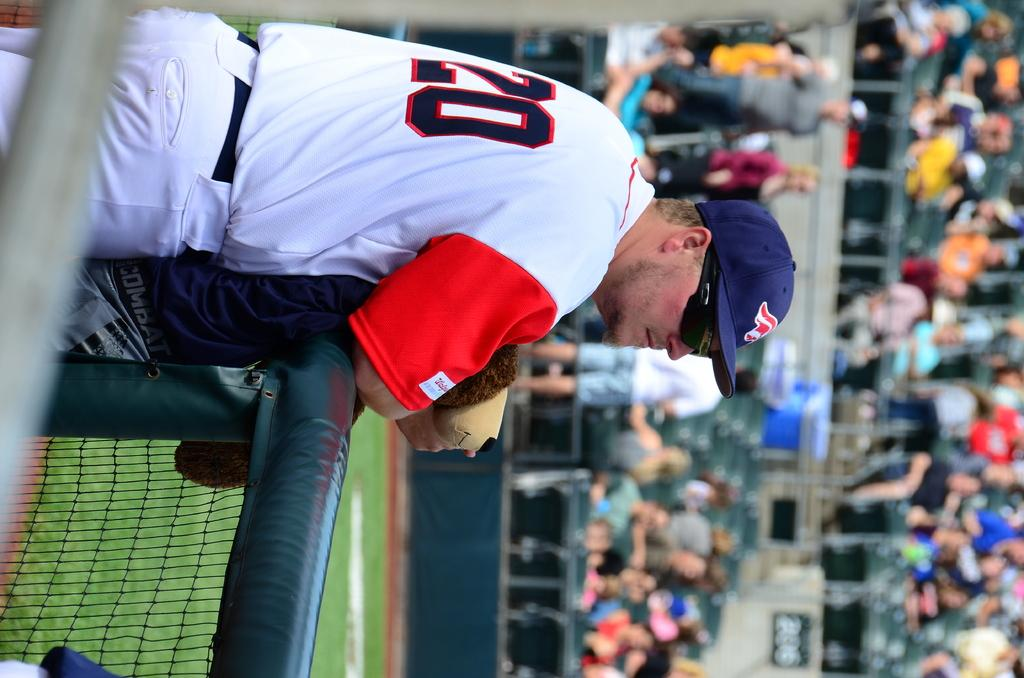Provide a one-sentence caption for the provided image. Player 20 standing next to the fence watching the game. 